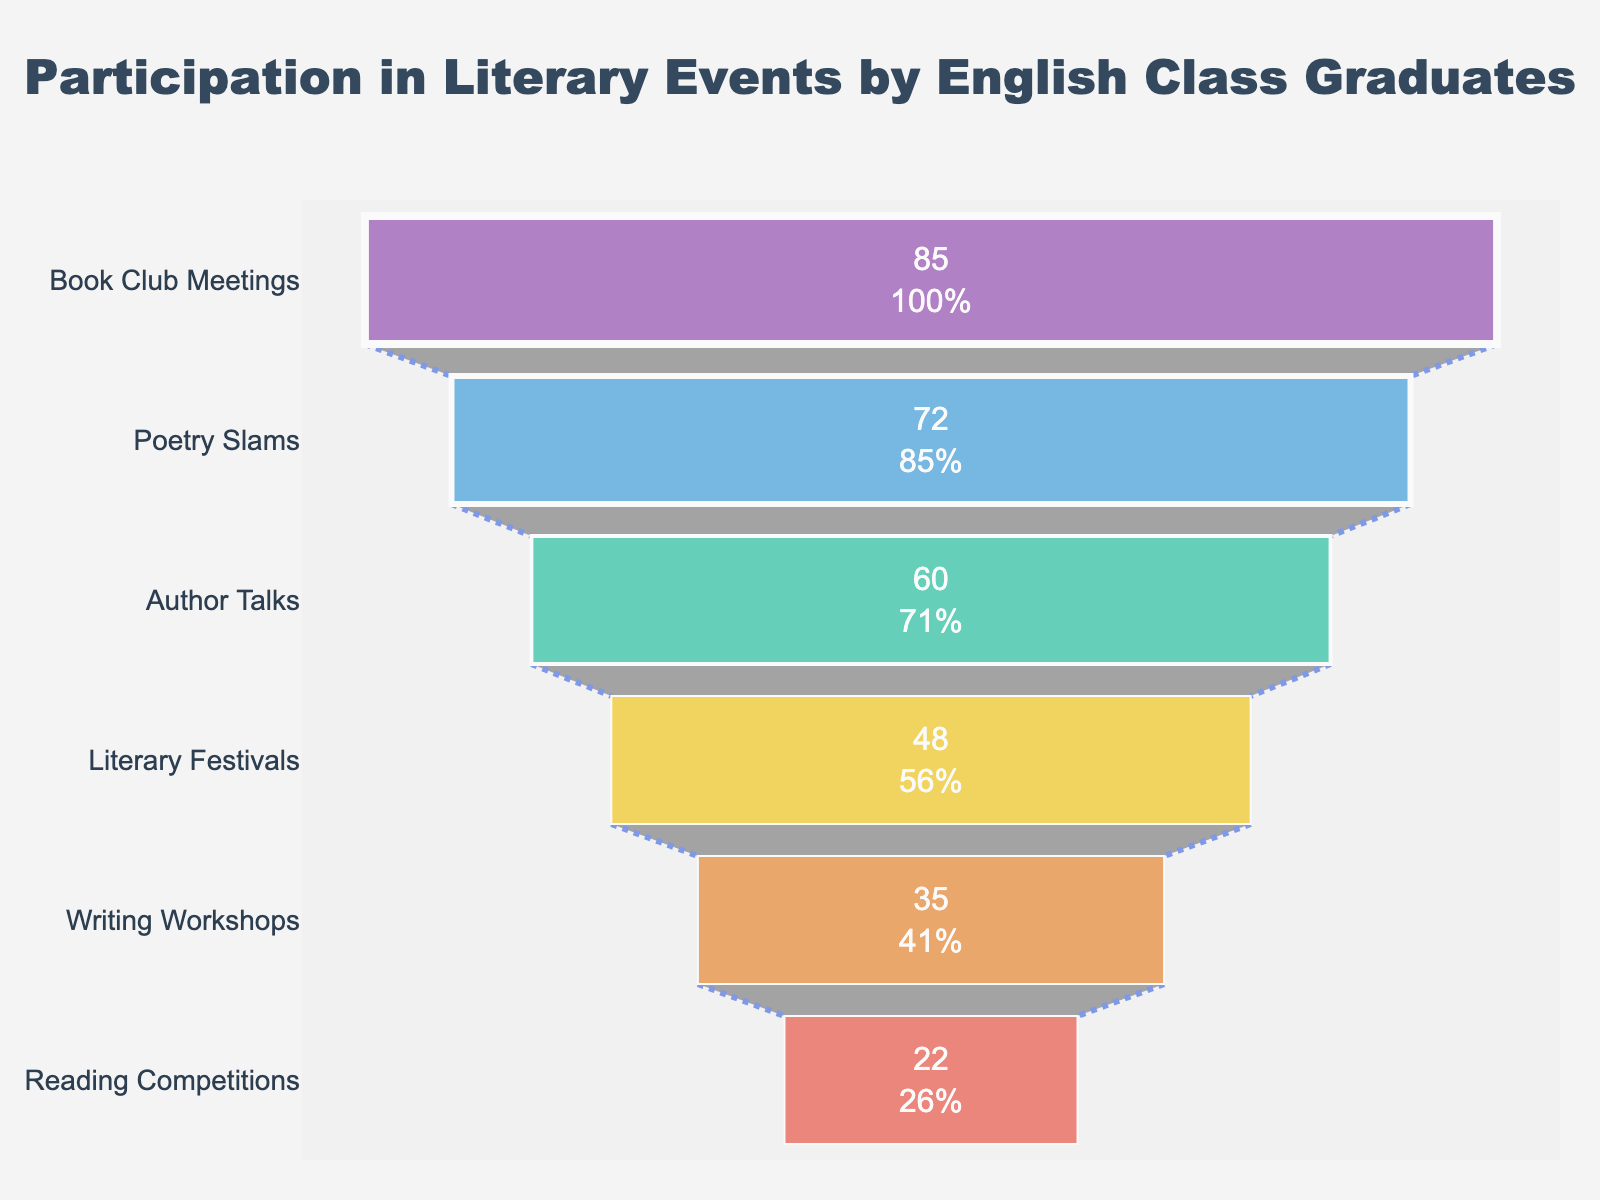How many events are listed in the funnel chart? Count the number of different events displayed on the funnel chart. Each bar represents one event.
Answer: 6 What is the participation rate for Poetry Slams? Locate the bar labeled "Poetry Slams" and read the corresponding participation rate value inside the bar.
Answer: 72 Which event has the lowest participation rate? Look for the smallest bar in the funnel chart and check the event's label on that bar.
Answer: Reading Competitions What is the total participation rate for Book Club Meetings and Writing Workshops? Find the participation rates for both events and sum them up: Book Club Meetings has 85 and Writing Workshops has 35. So, 85 + 35 = 120.
Answer: 120 How much higher is the participation rate for Literary Festivals than for Reading Competitions? Find the participation rates for both events: Literary Festivals (48) and Reading Competitions (22). Subtract the latter from the former: 48 - 22 = 26.
Answer: 26 Which three events have the highest participation rates, and what are their rates? Identify the top three bars in the funnel chart and note their labels and associated values: Book Club Meetings (85), Poetry Slams (72), and Author Talks (60).
Answer: Book Club Meetings (85), Poetry Slams (72), Author Talks (60) What percentage of the initial participants remain by the time we reach Literary Festivals? Determine the initial participation rate (85, from Book Club Meetings) and the participation rate for Literary Festivals (48). Calculate the percentage as (48 / 85) * 100 ≈ 56.47%.
Answer: ~56.47% What is the average participation rate across all events? Sum the participation rates for all events: 85 + 72 + 60 + 48 + 35 + 22 = 322. Divide by the number of events, which is 6: 322 / 6 ≈ 53.67.
Answer: ~53.67 Which event shows the greatest drop in participation from the previous event, and what is the drop amount? Calculate the differences between consecutive values: 
- Book Club Meetings to Poetry Slams: 85 - 72 = 13
- Poetry Slams to Author Talks: 72 - 60 = 12
- Author Talks to Literary Festivals: 60 - 48 = 12
- Literary Festivals to Writing Workshops: 48 - 35 = 13
- Writing Workshops to Reading Competitions: 35 - 22 = 13 
The greatest drop is 13, observed between multiple pairs.
Answer: 13 How many events have participation rates higher than the average participation rate? Compare each event's rate to the calculated average, ~53.67, and count those higher: Book Club Meetings (85), Poetry Slams (72), Author Talks (60). There are 3 such events.
Answer: 3 